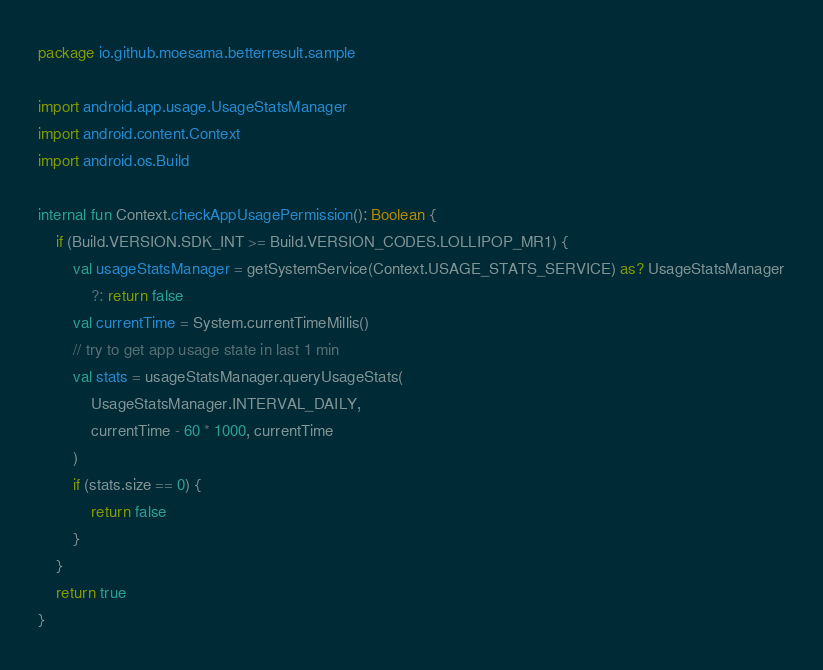Convert code to text. <code><loc_0><loc_0><loc_500><loc_500><_Kotlin_>package io.github.moesama.betterresult.sample

import android.app.usage.UsageStatsManager
import android.content.Context
import android.os.Build

internal fun Context.checkAppUsagePermission(): Boolean {
    if (Build.VERSION.SDK_INT >= Build.VERSION_CODES.LOLLIPOP_MR1) {
        val usageStatsManager = getSystemService(Context.USAGE_STATS_SERVICE) as? UsageStatsManager
            ?: return false
        val currentTime = System.currentTimeMillis()
        // try to get app usage state in last 1 min
        val stats = usageStatsManager.queryUsageStats(
            UsageStatsManager.INTERVAL_DAILY,
            currentTime - 60 * 1000, currentTime
        )
        if (stats.size == 0) {
            return false
        }
    }
    return true
}</code> 